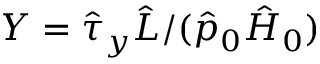Convert formula to latex. <formula><loc_0><loc_0><loc_500><loc_500>Y = \hat { \tau } _ { y } \hat { L } / ( \hat { p } _ { 0 } \hat { H } _ { 0 } )</formula> 